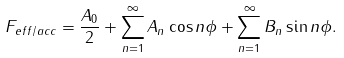Convert formula to latex. <formula><loc_0><loc_0><loc_500><loc_500>F _ { e f f / a c c } = \frac { A _ { 0 } } { 2 } + \sum _ { n = 1 } ^ { \infty } A _ { n } \cos { n \phi } + \sum _ { n = 1 } ^ { \infty } B _ { n } \sin { n \phi } .</formula> 